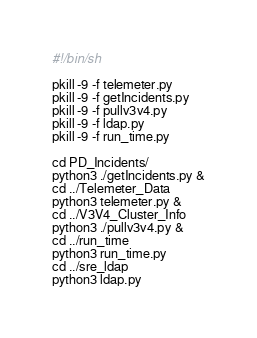<code> <loc_0><loc_0><loc_500><loc_500><_Bash_>#!/bin/sh

pkill -9 -f telemeter.py
pkill -9 -f getIncidents.py
pkill -9 -f pullv3v4.py
pkill -9 -f ldap.py
pkill -9 -f run_time.py

cd PD_Incidents/
python3 ./getIncidents.py &
cd ../Telemeter_Data
python3 telemeter.py &
cd ../V3V4_Cluster_Info
python3 ./pullv3v4.py &
cd ../run_time
python3 run_time.py
cd ../sre_ldap
python3 ldap.py
</code> 